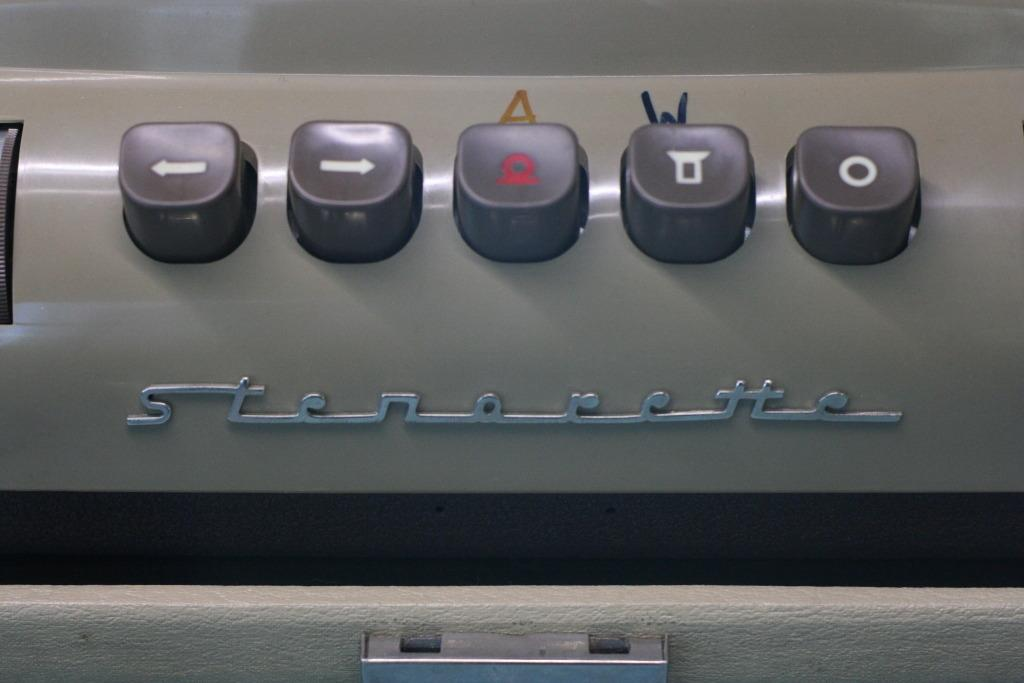<image>
Describe the image concisely. A gray Stenerette brand device with buttons that contains symbols on them 